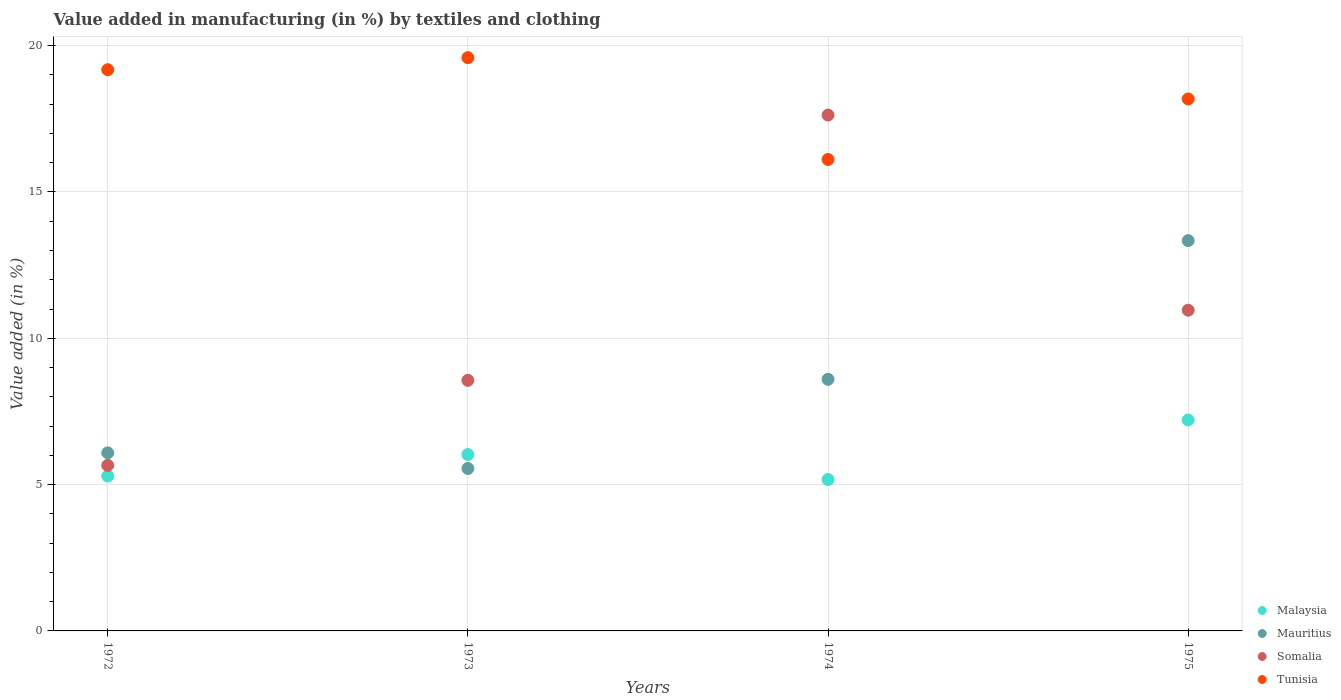How many different coloured dotlines are there?
Provide a short and direct response. 4. What is the percentage of value added in manufacturing by textiles and clothing in Malaysia in 1973?
Offer a very short reply. 6.03. Across all years, what is the maximum percentage of value added in manufacturing by textiles and clothing in Malaysia?
Provide a succinct answer. 7.21. Across all years, what is the minimum percentage of value added in manufacturing by textiles and clothing in Malaysia?
Offer a terse response. 5.17. In which year was the percentage of value added in manufacturing by textiles and clothing in Somalia maximum?
Your answer should be compact. 1974. In which year was the percentage of value added in manufacturing by textiles and clothing in Malaysia minimum?
Offer a terse response. 1974. What is the total percentage of value added in manufacturing by textiles and clothing in Tunisia in the graph?
Your response must be concise. 73.06. What is the difference between the percentage of value added in manufacturing by textiles and clothing in Tunisia in 1973 and that in 1974?
Keep it short and to the point. 3.48. What is the difference between the percentage of value added in manufacturing by textiles and clothing in Mauritius in 1975 and the percentage of value added in manufacturing by textiles and clothing in Malaysia in 1974?
Offer a terse response. 8.16. What is the average percentage of value added in manufacturing by textiles and clothing in Tunisia per year?
Your response must be concise. 18.27. In the year 1975, what is the difference between the percentage of value added in manufacturing by textiles and clothing in Malaysia and percentage of value added in manufacturing by textiles and clothing in Tunisia?
Give a very brief answer. -10.97. What is the ratio of the percentage of value added in manufacturing by textiles and clothing in Somalia in 1973 to that in 1974?
Offer a very short reply. 0.49. Is the percentage of value added in manufacturing by textiles and clothing in Somalia in 1973 less than that in 1975?
Keep it short and to the point. Yes. What is the difference between the highest and the second highest percentage of value added in manufacturing by textiles and clothing in Tunisia?
Your answer should be very brief. 0.41. What is the difference between the highest and the lowest percentage of value added in manufacturing by textiles and clothing in Malaysia?
Make the answer very short. 2.04. In how many years, is the percentage of value added in manufacturing by textiles and clothing in Malaysia greater than the average percentage of value added in manufacturing by textiles and clothing in Malaysia taken over all years?
Your response must be concise. 2. Is the sum of the percentage of value added in manufacturing by textiles and clothing in Somalia in 1972 and 1974 greater than the maximum percentage of value added in manufacturing by textiles and clothing in Tunisia across all years?
Offer a very short reply. Yes. Is it the case that in every year, the sum of the percentage of value added in manufacturing by textiles and clothing in Malaysia and percentage of value added in manufacturing by textiles and clothing in Somalia  is greater than the sum of percentage of value added in manufacturing by textiles and clothing in Mauritius and percentage of value added in manufacturing by textiles and clothing in Tunisia?
Offer a terse response. No. Is it the case that in every year, the sum of the percentage of value added in manufacturing by textiles and clothing in Somalia and percentage of value added in manufacturing by textiles and clothing in Malaysia  is greater than the percentage of value added in manufacturing by textiles and clothing in Mauritius?
Make the answer very short. Yes. Is the percentage of value added in manufacturing by textiles and clothing in Tunisia strictly greater than the percentage of value added in manufacturing by textiles and clothing in Somalia over the years?
Offer a terse response. No. Is the percentage of value added in manufacturing by textiles and clothing in Malaysia strictly less than the percentage of value added in manufacturing by textiles and clothing in Tunisia over the years?
Ensure brevity in your answer.  Yes. How many dotlines are there?
Provide a succinct answer. 4. How many years are there in the graph?
Keep it short and to the point. 4. What is the difference between two consecutive major ticks on the Y-axis?
Keep it short and to the point. 5. Are the values on the major ticks of Y-axis written in scientific E-notation?
Provide a short and direct response. No. Does the graph contain grids?
Offer a terse response. Yes. Where does the legend appear in the graph?
Your answer should be compact. Bottom right. How many legend labels are there?
Your answer should be compact. 4. What is the title of the graph?
Provide a short and direct response. Value added in manufacturing (in %) by textiles and clothing. Does "Tajikistan" appear as one of the legend labels in the graph?
Your response must be concise. No. What is the label or title of the Y-axis?
Give a very brief answer. Value added (in %). What is the Value added (in %) of Malaysia in 1972?
Your response must be concise. 5.29. What is the Value added (in %) in Mauritius in 1972?
Give a very brief answer. 6.09. What is the Value added (in %) in Somalia in 1972?
Provide a succinct answer. 5.66. What is the Value added (in %) in Tunisia in 1972?
Provide a short and direct response. 19.18. What is the Value added (in %) in Malaysia in 1973?
Make the answer very short. 6.03. What is the Value added (in %) in Mauritius in 1973?
Provide a short and direct response. 5.55. What is the Value added (in %) of Somalia in 1973?
Your answer should be very brief. 8.56. What is the Value added (in %) in Tunisia in 1973?
Offer a terse response. 19.59. What is the Value added (in %) in Malaysia in 1974?
Your answer should be very brief. 5.17. What is the Value added (in %) of Mauritius in 1974?
Your answer should be very brief. 8.6. What is the Value added (in %) in Somalia in 1974?
Your answer should be compact. 17.63. What is the Value added (in %) in Tunisia in 1974?
Keep it short and to the point. 16.11. What is the Value added (in %) in Malaysia in 1975?
Offer a terse response. 7.21. What is the Value added (in %) in Mauritius in 1975?
Your answer should be compact. 13.34. What is the Value added (in %) in Somalia in 1975?
Provide a short and direct response. 10.96. What is the Value added (in %) of Tunisia in 1975?
Offer a very short reply. 18.18. Across all years, what is the maximum Value added (in %) in Malaysia?
Ensure brevity in your answer.  7.21. Across all years, what is the maximum Value added (in %) of Mauritius?
Offer a terse response. 13.34. Across all years, what is the maximum Value added (in %) of Somalia?
Make the answer very short. 17.63. Across all years, what is the maximum Value added (in %) of Tunisia?
Your answer should be very brief. 19.59. Across all years, what is the minimum Value added (in %) of Malaysia?
Ensure brevity in your answer.  5.17. Across all years, what is the minimum Value added (in %) in Mauritius?
Make the answer very short. 5.55. Across all years, what is the minimum Value added (in %) of Somalia?
Your response must be concise. 5.66. Across all years, what is the minimum Value added (in %) of Tunisia?
Make the answer very short. 16.11. What is the total Value added (in %) in Malaysia in the graph?
Provide a short and direct response. 23.7. What is the total Value added (in %) of Mauritius in the graph?
Keep it short and to the point. 33.57. What is the total Value added (in %) of Somalia in the graph?
Your answer should be compact. 42.81. What is the total Value added (in %) in Tunisia in the graph?
Your response must be concise. 73.06. What is the difference between the Value added (in %) of Malaysia in 1972 and that in 1973?
Offer a very short reply. -0.74. What is the difference between the Value added (in %) in Mauritius in 1972 and that in 1973?
Make the answer very short. 0.53. What is the difference between the Value added (in %) of Somalia in 1972 and that in 1973?
Provide a succinct answer. -2.91. What is the difference between the Value added (in %) in Tunisia in 1972 and that in 1973?
Offer a terse response. -0.41. What is the difference between the Value added (in %) in Malaysia in 1972 and that in 1974?
Ensure brevity in your answer.  0.12. What is the difference between the Value added (in %) of Mauritius in 1972 and that in 1974?
Keep it short and to the point. -2.51. What is the difference between the Value added (in %) in Somalia in 1972 and that in 1974?
Provide a succinct answer. -11.97. What is the difference between the Value added (in %) of Tunisia in 1972 and that in 1974?
Your answer should be very brief. 3.07. What is the difference between the Value added (in %) of Malaysia in 1972 and that in 1975?
Keep it short and to the point. -1.92. What is the difference between the Value added (in %) of Mauritius in 1972 and that in 1975?
Your response must be concise. -7.25. What is the difference between the Value added (in %) of Somalia in 1972 and that in 1975?
Offer a very short reply. -5.3. What is the difference between the Value added (in %) in Tunisia in 1972 and that in 1975?
Ensure brevity in your answer.  1. What is the difference between the Value added (in %) in Malaysia in 1973 and that in 1974?
Your answer should be compact. 0.85. What is the difference between the Value added (in %) in Mauritius in 1973 and that in 1974?
Offer a very short reply. -3.05. What is the difference between the Value added (in %) of Somalia in 1973 and that in 1974?
Keep it short and to the point. -9.07. What is the difference between the Value added (in %) of Tunisia in 1973 and that in 1974?
Keep it short and to the point. 3.48. What is the difference between the Value added (in %) of Malaysia in 1973 and that in 1975?
Offer a very short reply. -1.18. What is the difference between the Value added (in %) of Mauritius in 1973 and that in 1975?
Provide a succinct answer. -7.79. What is the difference between the Value added (in %) in Somalia in 1973 and that in 1975?
Your answer should be compact. -2.4. What is the difference between the Value added (in %) of Tunisia in 1973 and that in 1975?
Give a very brief answer. 1.41. What is the difference between the Value added (in %) in Malaysia in 1974 and that in 1975?
Give a very brief answer. -2.04. What is the difference between the Value added (in %) in Mauritius in 1974 and that in 1975?
Offer a very short reply. -4.74. What is the difference between the Value added (in %) of Somalia in 1974 and that in 1975?
Offer a terse response. 6.67. What is the difference between the Value added (in %) of Tunisia in 1974 and that in 1975?
Your response must be concise. -2.07. What is the difference between the Value added (in %) of Malaysia in 1972 and the Value added (in %) of Mauritius in 1973?
Offer a terse response. -0.26. What is the difference between the Value added (in %) in Malaysia in 1972 and the Value added (in %) in Somalia in 1973?
Provide a short and direct response. -3.27. What is the difference between the Value added (in %) of Malaysia in 1972 and the Value added (in %) of Tunisia in 1973?
Offer a very short reply. -14.3. What is the difference between the Value added (in %) of Mauritius in 1972 and the Value added (in %) of Somalia in 1973?
Make the answer very short. -2.48. What is the difference between the Value added (in %) of Mauritius in 1972 and the Value added (in %) of Tunisia in 1973?
Your answer should be very brief. -13.51. What is the difference between the Value added (in %) in Somalia in 1972 and the Value added (in %) in Tunisia in 1973?
Your answer should be very brief. -13.93. What is the difference between the Value added (in %) in Malaysia in 1972 and the Value added (in %) in Mauritius in 1974?
Make the answer very short. -3.31. What is the difference between the Value added (in %) of Malaysia in 1972 and the Value added (in %) of Somalia in 1974?
Provide a short and direct response. -12.34. What is the difference between the Value added (in %) in Malaysia in 1972 and the Value added (in %) in Tunisia in 1974?
Offer a very short reply. -10.82. What is the difference between the Value added (in %) in Mauritius in 1972 and the Value added (in %) in Somalia in 1974?
Provide a short and direct response. -11.54. What is the difference between the Value added (in %) in Mauritius in 1972 and the Value added (in %) in Tunisia in 1974?
Offer a terse response. -10.03. What is the difference between the Value added (in %) in Somalia in 1972 and the Value added (in %) in Tunisia in 1974?
Provide a succinct answer. -10.45. What is the difference between the Value added (in %) of Malaysia in 1972 and the Value added (in %) of Mauritius in 1975?
Offer a terse response. -8.05. What is the difference between the Value added (in %) in Malaysia in 1972 and the Value added (in %) in Somalia in 1975?
Make the answer very short. -5.67. What is the difference between the Value added (in %) in Malaysia in 1972 and the Value added (in %) in Tunisia in 1975?
Provide a short and direct response. -12.89. What is the difference between the Value added (in %) in Mauritius in 1972 and the Value added (in %) in Somalia in 1975?
Ensure brevity in your answer.  -4.87. What is the difference between the Value added (in %) of Mauritius in 1972 and the Value added (in %) of Tunisia in 1975?
Give a very brief answer. -12.09. What is the difference between the Value added (in %) in Somalia in 1972 and the Value added (in %) in Tunisia in 1975?
Make the answer very short. -12.52. What is the difference between the Value added (in %) in Malaysia in 1973 and the Value added (in %) in Mauritius in 1974?
Your answer should be compact. -2.57. What is the difference between the Value added (in %) in Malaysia in 1973 and the Value added (in %) in Somalia in 1974?
Your answer should be compact. -11.6. What is the difference between the Value added (in %) of Malaysia in 1973 and the Value added (in %) of Tunisia in 1974?
Provide a succinct answer. -10.08. What is the difference between the Value added (in %) in Mauritius in 1973 and the Value added (in %) in Somalia in 1974?
Provide a succinct answer. -12.08. What is the difference between the Value added (in %) of Mauritius in 1973 and the Value added (in %) of Tunisia in 1974?
Offer a terse response. -10.56. What is the difference between the Value added (in %) in Somalia in 1973 and the Value added (in %) in Tunisia in 1974?
Your answer should be compact. -7.55. What is the difference between the Value added (in %) of Malaysia in 1973 and the Value added (in %) of Mauritius in 1975?
Offer a terse response. -7.31. What is the difference between the Value added (in %) of Malaysia in 1973 and the Value added (in %) of Somalia in 1975?
Your answer should be compact. -4.93. What is the difference between the Value added (in %) in Malaysia in 1973 and the Value added (in %) in Tunisia in 1975?
Give a very brief answer. -12.15. What is the difference between the Value added (in %) of Mauritius in 1973 and the Value added (in %) of Somalia in 1975?
Your response must be concise. -5.41. What is the difference between the Value added (in %) of Mauritius in 1973 and the Value added (in %) of Tunisia in 1975?
Offer a terse response. -12.63. What is the difference between the Value added (in %) in Somalia in 1973 and the Value added (in %) in Tunisia in 1975?
Offer a terse response. -9.62. What is the difference between the Value added (in %) of Malaysia in 1974 and the Value added (in %) of Mauritius in 1975?
Your answer should be compact. -8.16. What is the difference between the Value added (in %) of Malaysia in 1974 and the Value added (in %) of Somalia in 1975?
Make the answer very short. -5.79. What is the difference between the Value added (in %) in Malaysia in 1974 and the Value added (in %) in Tunisia in 1975?
Make the answer very short. -13.01. What is the difference between the Value added (in %) of Mauritius in 1974 and the Value added (in %) of Somalia in 1975?
Provide a short and direct response. -2.36. What is the difference between the Value added (in %) of Mauritius in 1974 and the Value added (in %) of Tunisia in 1975?
Provide a short and direct response. -9.58. What is the difference between the Value added (in %) of Somalia in 1974 and the Value added (in %) of Tunisia in 1975?
Give a very brief answer. -0.55. What is the average Value added (in %) in Malaysia per year?
Give a very brief answer. 5.93. What is the average Value added (in %) in Mauritius per year?
Ensure brevity in your answer.  8.39. What is the average Value added (in %) in Somalia per year?
Offer a terse response. 10.7. What is the average Value added (in %) in Tunisia per year?
Provide a succinct answer. 18.27. In the year 1972, what is the difference between the Value added (in %) in Malaysia and Value added (in %) in Mauritius?
Provide a succinct answer. -0.79. In the year 1972, what is the difference between the Value added (in %) in Malaysia and Value added (in %) in Somalia?
Offer a very short reply. -0.37. In the year 1972, what is the difference between the Value added (in %) in Malaysia and Value added (in %) in Tunisia?
Provide a short and direct response. -13.89. In the year 1972, what is the difference between the Value added (in %) in Mauritius and Value added (in %) in Somalia?
Provide a succinct answer. 0.43. In the year 1972, what is the difference between the Value added (in %) of Mauritius and Value added (in %) of Tunisia?
Provide a short and direct response. -13.09. In the year 1972, what is the difference between the Value added (in %) in Somalia and Value added (in %) in Tunisia?
Ensure brevity in your answer.  -13.52. In the year 1973, what is the difference between the Value added (in %) of Malaysia and Value added (in %) of Mauritius?
Make the answer very short. 0.48. In the year 1973, what is the difference between the Value added (in %) of Malaysia and Value added (in %) of Somalia?
Your response must be concise. -2.54. In the year 1973, what is the difference between the Value added (in %) in Malaysia and Value added (in %) in Tunisia?
Ensure brevity in your answer.  -13.56. In the year 1973, what is the difference between the Value added (in %) of Mauritius and Value added (in %) of Somalia?
Your answer should be compact. -3.01. In the year 1973, what is the difference between the Value added (in %) in Mauritius and Value added (in %) in Tunisia?
Give a very brief answer. -14.04. In the year 1973, what is the difference between the Value added (in %) in Somalia and Value added (in %) in Tunisia?
Your answer should be very brief. -11.03. In the year 1974, what is the difference between the Value added (in %) of Malaysia and Value added (in %) of Mauritius?
Provide a short and direct response. -3.42. In the year 1974, what is the difference between the Value added (in %) of Malaysia and Value added (in %) of Somalia?
Provide a succinct answer. -12.45. In the year 1974, what is the difference between the Value added (in %) of Malaysia and Value added (in %) of Tunisia?
Your answer should be compact. -10.94. In the year 1974, what is the difference between the Value added (in %) of Mauritius and Value added (in %) of Somalia?
Provide a succinct answer. -9.03. In the year 1974, what is the difference between the Value added (in %) of Mauritius and Value added (in %) of Tunisia?
Ensure brevity in your answer.  -7.51. In the year 1974, what is the difference between the Value added (in %) of Somalia and Value added (in %) of Tunisia?
Give a very brief answer. 1.52. In the year 1975, what is the difference between the Value added (in %) in Malaysia and Value added (in %) in Mauritius?
Your answer should be compact. -6.13. In the year 1975, what is the difference between the Value added (in %) in Malaysia and Value added (in %) in Somalia?
Your answer should be very brief. -3.75. In the year 1975, what is the difference between the Value added (in %) of Malaysia and Value added (in %) of Tunisia?
Keep it short and to the point. -10.97. In the year 1975, what is the difference between the Value added (in %) of Mauritius and Value added (in %) of Somalia?
Offer a very short reply. 2.38. In the year 1975, what is the difference between the Value added (in %) in Mauritius and Value added (in %) in Tunisia?
Offer a terse response. -4.84. In the year 1975, what is the difference between the Value added (in %) of Somalia and Value added (in %) of Tunisia?
Offer a very short reply. -7.22. What is the ratio of the Value added (in %) in Malaysia in 1972 to that in 1973?
Your response must be concise. 0.88. What is the ratio of the Value added (in %) of Mauritius in 1972 to that in 1973?
Ensure brevity in your answer.  1.1. What is the ratio of the Value added (in %) of Somalia in 1972 to that in 1973?
Ensure brevity in your answer.  0.66. What is the ratio of the Value added (in %) in Malaysia in 1972 to that in 1974?
Give a very brief answer. 1.02. What is the ratio of the Value added (in %) of Mauritius in 1972 to that in 1974?
Offer a very short reply. 0.71. What is the ratio of the Value added (in %) in Somalia in 1972 to that in 1974?
Give a very brief answer. 0.32. What is the ratio of the Value added (in %) in Tunisia in 1972 to that in 1974?
Provide a succinct answer. 1.19. What is the ratio of the Value added (in %) in Malaysia in 1972 to that in 1975?
Keep it short and to the point. 0.73. What is the ratio of the Value added (in %) of Mauritius in 1972 to that in 1975?
Offer a very short reply. 0.46. What is the ratio of the Value added (in %) of Somalia in 1972 to that in 1975?
Your response must be concise. 0.52. What is the ratio of the Value added (in %) in Tunisia in 1972 to that in 1975?
Keep it short and to the point. 1.05. What is the ratio of the Value added (in %) of Malaysia in 1973 to that in 1974?
Make the answer very short. 1.16. What is the ratio of the Value added (in %) in Mauritius in 1973 to that in 1974?
Provide a short and direct response. 0.65. What is the ratio of the Value added (in %) in Somalia in 1973 to that in 1974?
Give a very brief answer. 0.49. What is the ratio of the Value added (in %) in Tunisia in 1973 to that in 1974?
Keep it short and to the point. 1.22. What is the ratio of the Value added (in %) of Malaysia in 1973 to that in 1975?
Keep it short and to the point. 0.84. What is the ratio of the Value added (in %) in Mauritius in 1973 to that in 1975?
Your answer should be compact. 0.42. What is the ratio of the Value added (in %) in Somalia in 1973 to that in 1975?
Your response must be concise. 0.78. What is the ratio of the Value added (in %) in Tunisia in 1973 to that in 1975?
Ensure brevity in your answer.  1.08. What is the ratio of the Value added (in %) of Malaysia in 1974 to that in 1975?
Offer a very short reply. 0.72. What is the ratio of the Value added (in %) in Mauritius in 1974 to that in 1975?
Provide a short and direct response. 0.64. What is the ratio of the Value added (in %) of Somalia in 1974 to that in 1975?
Ensure brevity in your answer.  1.61. What is the ratio of the Value added (in %) of Tunisia in 1974 to that in 1975?
Provide a succinct answer. 0.89. What is the difference between the highest and the second highest Value added (in %) of Malaysia?
Ensure brevity in your answer.  1.18. What is the difference between the highest and the second highest Value added (in %) of Mauritius?
Your answer should be compact. 4.74. What is the difference between the highest and the second highest Value added (in %) of Somalia?
Offer a very short reply. 6.67. What is the difference between the highest and the second highest Value added (in %) of Tunisia?
Your response must be concise. 0.41. What is the difference between the highest and the lowest Value added (in %) of Malaysia?
Offer a very short reply. 2.04. What is the difference between the highest and the lowest Value added (in %) in Mauritius?
Keep it short and to the point. 7.79. What is the difference between the highest and the lowest Value added (in %) in Somalia?
Make the answer very short. 11.97. What is the difference between the highest and the lowest Value added (in %) of Tunisia?
Make the answer very short. 3.48. 